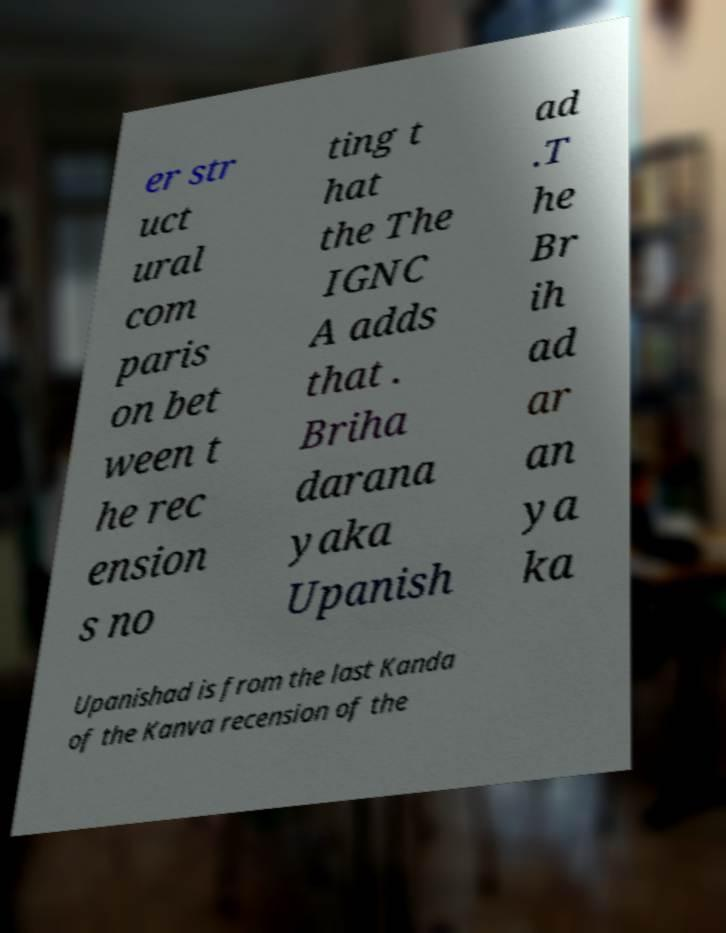Could you assist in decoding the text presented in this image and type it out clearly? er str uct ural com paris on bet ween t he rec ension s no ting t hat the The IGNC A adds that . Briha darana yaka Upanish ad .T he Br ih ad ar an ya ka Upanishad is from the last Kanda of the Kanva recension of the 